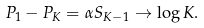Convert formula to latex. <formula><loc_0><loc_0><loc_500><loc_500>P _ { 1 } - P _ { K } = \alpha S _ { K - 1 } \to \log K .</formula> 